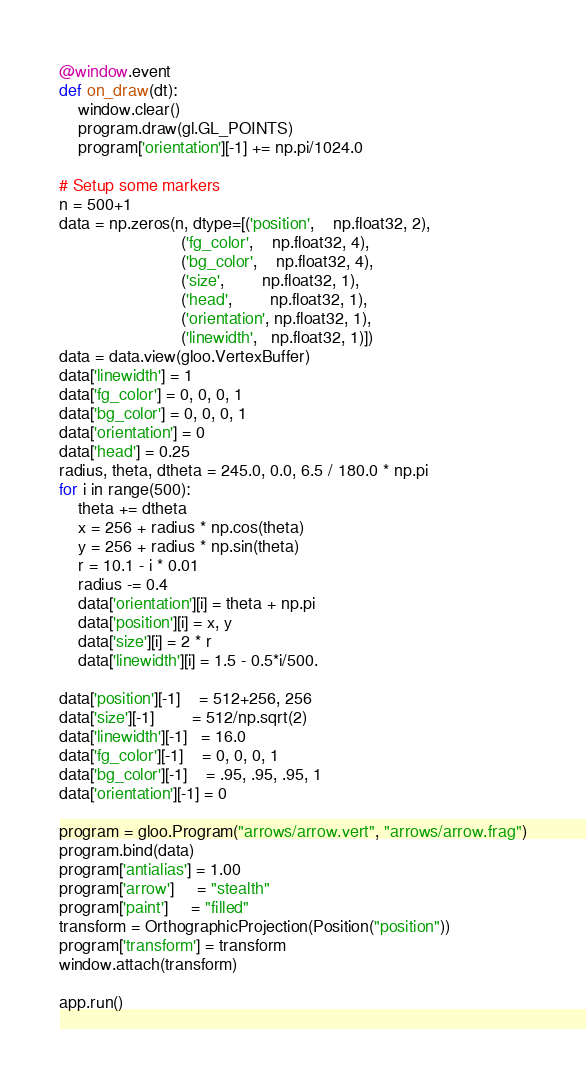<code> <loc_0><loc_0><loc_500><loc_500><_Python_>@window.event
def on_draw(dt):
    window.clear()
    program.draw(gl.GL_POINTS)
    program['orientation'][-1] += np.pi/1024.0

# Setup some markers
n = 500+1
data = np.zeros(n, dtype=[('position',    np.float32, 2),
                          ('fg_color',    np.float32, 4),
                          ('bg_color',    np.float32, 4),
                          ('size',        np.float32, 1),
                          ('head',        np.float32, 1),
                          ('orientation', np.float32, 1),
                          ('linewidth',   np.float32, 1)])
data = data.view(gloo.VertexBuffer)
data['linewidth'] = 1
data['fg_color'] = 0, 0, 0, 1
data['bg_color'] = 0, 0, 0, 1
data['orientation'] = 0
data['head'] = 0.25
radius, theta, dtheta = 245.0, 0.0, 6.5 / 180.0 * np.pi
for i in range(500):
    theta += dtheta
    x = 256 + radius * np.cos(theta)
    y = 256 + radius * np.sin(theta)
    r = 10.1 - i * 0.01
    radius -= 0.4
    data['orientation'][i] = theta + np.pi
    data['position'][i] = x, y
    data['size'][i] = 2 * r
    data['linewidth'][i] = 1.5 - 0.5*i/500.

data['position'][-1]    = 512+256, 256
data['size'][-1]        = 512/np.sqrt(2)
data['linewidth'][-1]   = 16.0
data['fg_color'][-1]    = 0, 0, 0, 1
data['bg_color'][-1]    = .95, .95, .95, 1
data['orientation'][-1] = 0

program = gloo.Program("arrows/arrow.vert", "arrows/arrow.frag")
program.bind(data)
program['antialias'] = 1.00
program['arrow']     = "stealth"
program['paint']     = "filled"
transform = OrthographicProjection(Position("position"))
program['transform'] = transform
window.attach(transform)

app.run()
</code> 